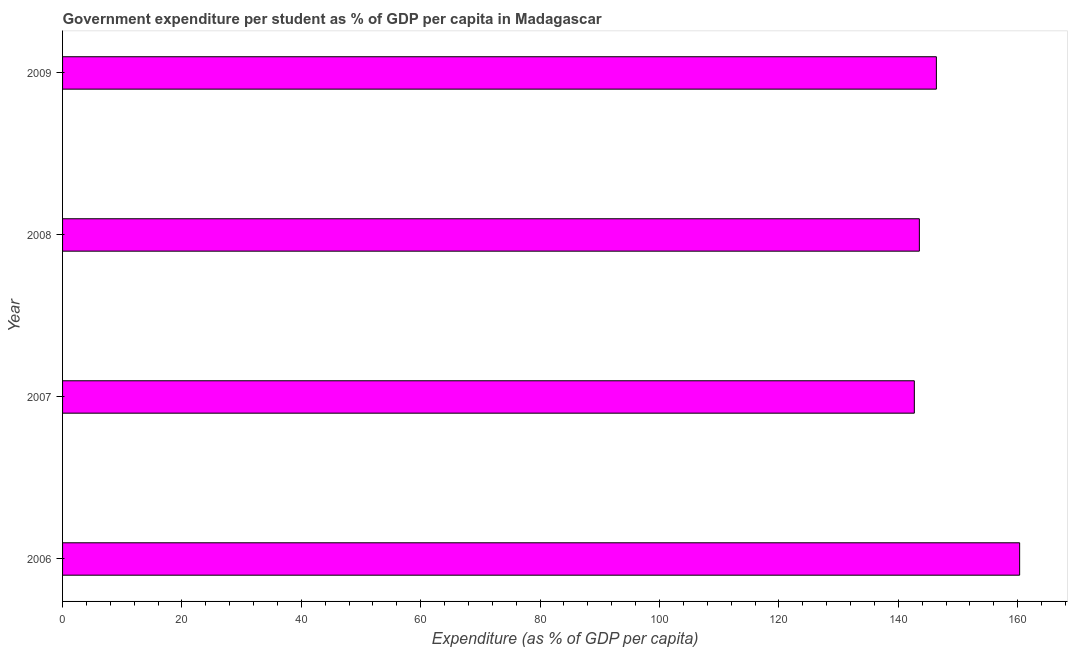What is the title of the graph?
Keep it short and to the point. Government expenditure per student as % of GDP per capita in Madagascar. What is the label or title of the X-axis?
Ensure brevity in your answer.  Expenditure (as % of GDP per capita). What is the government expenditure per student in 2006?
Your response must be concise. 160.33. Across all years, what is the maximum government expenditure per student?
Your answer should be very brief. 160.33. Across all years, what is the minimum government expenditure per student?
Offer a very short reply. 142.69. What is the sum of the government expenditure per student?
Offer a terse response. 592.94. What is the difference between the government expenditure per student in 2007 and 2009?
Keep it short and to the point. -3.69. What is the average government expenditure per student per year?
Offer a very short reply. 148.24. What is the median government expenditure per student?
Offer a very short reply. 144.96. Do a majority of the years between 2009 and 2006 (inclusive) have government expenditure per student greater than 156 %?
Ensure brevity in your answer.  Yes. Is the government expenditure per student in 2006 less than that in 2009?
Your answer should be very brief. No. What is the difference between the highest and the second highest government expenditure per student?
Offer a very short reply. 13.95. What is the difference between the highest and the lowest government expenditure per student?
Offer a very short reply. 17.64. In how many years, is the government expenditure per student greater than the average government expenditure per student taken over all years?
Keep it short and to the point. 1. How many bars are there?
Your answer should be compact. 4. Are all the bars in the graph horizontal?
Your response must be concise. Yes. How many years are there in the graph?
Ensure brevity in your answer.  4. Are the values on the major ticks of X-axis written in scientific E-notation?
Make the answer very short. No. What is the Expenditure (as % of GDP per capita) of 2006?
Offer a very short reply. 160.33. What is the Expenditure (as % of GDP per capita) in 2007?
Give a very brief answer. 142.69. What is the Expenditure (as % of GDP per capita) of 2008?
Keep it short and to the point. 143.53. What is the Expenditure (as % of GDP per capita) in 2009?
Offer a very short reply. 146.38. What is the difference between the Expenditure (as % of GDP per capita) in 2006 and 2007?
Offer a very short reply. 17.64. What is the difference between the Expenditure (as % of GDP per capita) in 2006 and 2008?
Offer a terse response. 16.8. What is the difference between the Expenditure (as % of GDP per capita) in 2006 and 2009?
Your answer should be compact. 13.95. What is the difference between the Expenditure (as % of GDP per capita) in 2007 and 2008?
Keep it short and to the point. -0.84. What is the difference between the Expenditure (as % of GDP per capita) in 2007 and 2009?
Give a very brief answer. -3.69. What is the difference between the Expenditure (as % of GDP per capita) in 2008 and 2009?
Offer a very short reply. -2.85. What is the ratio of the Expenditure (as % of GDP per capita) in 2006 to that in 2007?
Ensure brevity in your answer.  1.12. What is the ratio of the Expenditure (as % of GDP per capita) in 2006 to that in 2008?
Keep it short and to the point. 1.12. What is the ratio of the Expenditure (as % of GDP per capita) in 2006 to that in 2009?
Offer a very short reply. 1.09. What is the ratio of the Expenditure (as % of GDP per capita) in 2007 to that in 2008?
Offer a terse response. 0.99. What is the ratio of the Expenditure (as % of GDP per capita) in 2007 to that in 2009?
Your response must be concise. 0.97. What is the ratio of the Expenditure (as % of GDP per capita) in 2008 to that in 2009?
Your answer should be very brief. 0.98. 